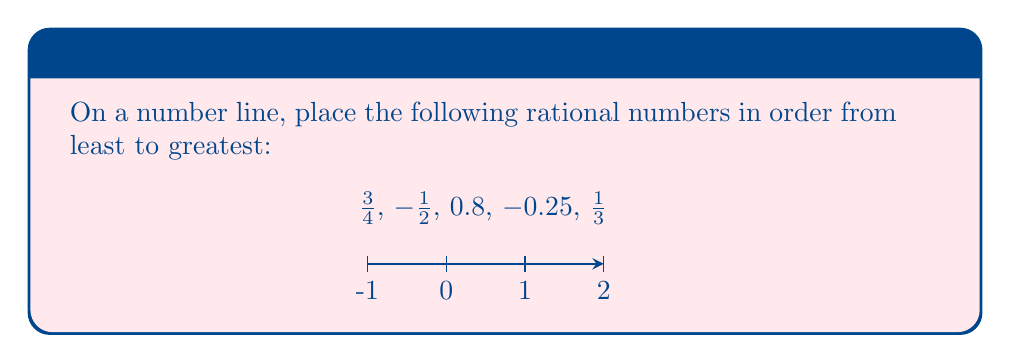Give your solution to this math problem. To compare and order rational numbers on a number line, we need to convert them to a common representation. Let's convert all numbers to decimals:

1. $\frac{3}{4} = 0.75$
2. $-\frac{1}{2} = -0.5$
3. $0.8$ is already in decimal form
4. $-0.25$ is already in decimal form
5. $\frac{1}{3} \approx 0.333$ (rounded to 3 decimal places)

Now, we can order these numbers from least to greatest:

$-0.5 < -0.25 < 0.333 < 0.75 < 0.8$

Converting back to the original representations:

$-\frac{1}{2} < -0.25 < \frac{1}{3} < \frac{3}{4} < 0.8$
Answer: $-\frac{1}{2}, -0.25, \frac{1}{3}, \frac{3}{4}, 0.8$ 